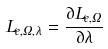Convert formula to latex. <formula><loc_0><loc_0><loc_500><loc_500>L _ { e , \Omega , \lambda } = \frac { \partial L _ { e , \Omega } } { \partial \lambda }</formula> 